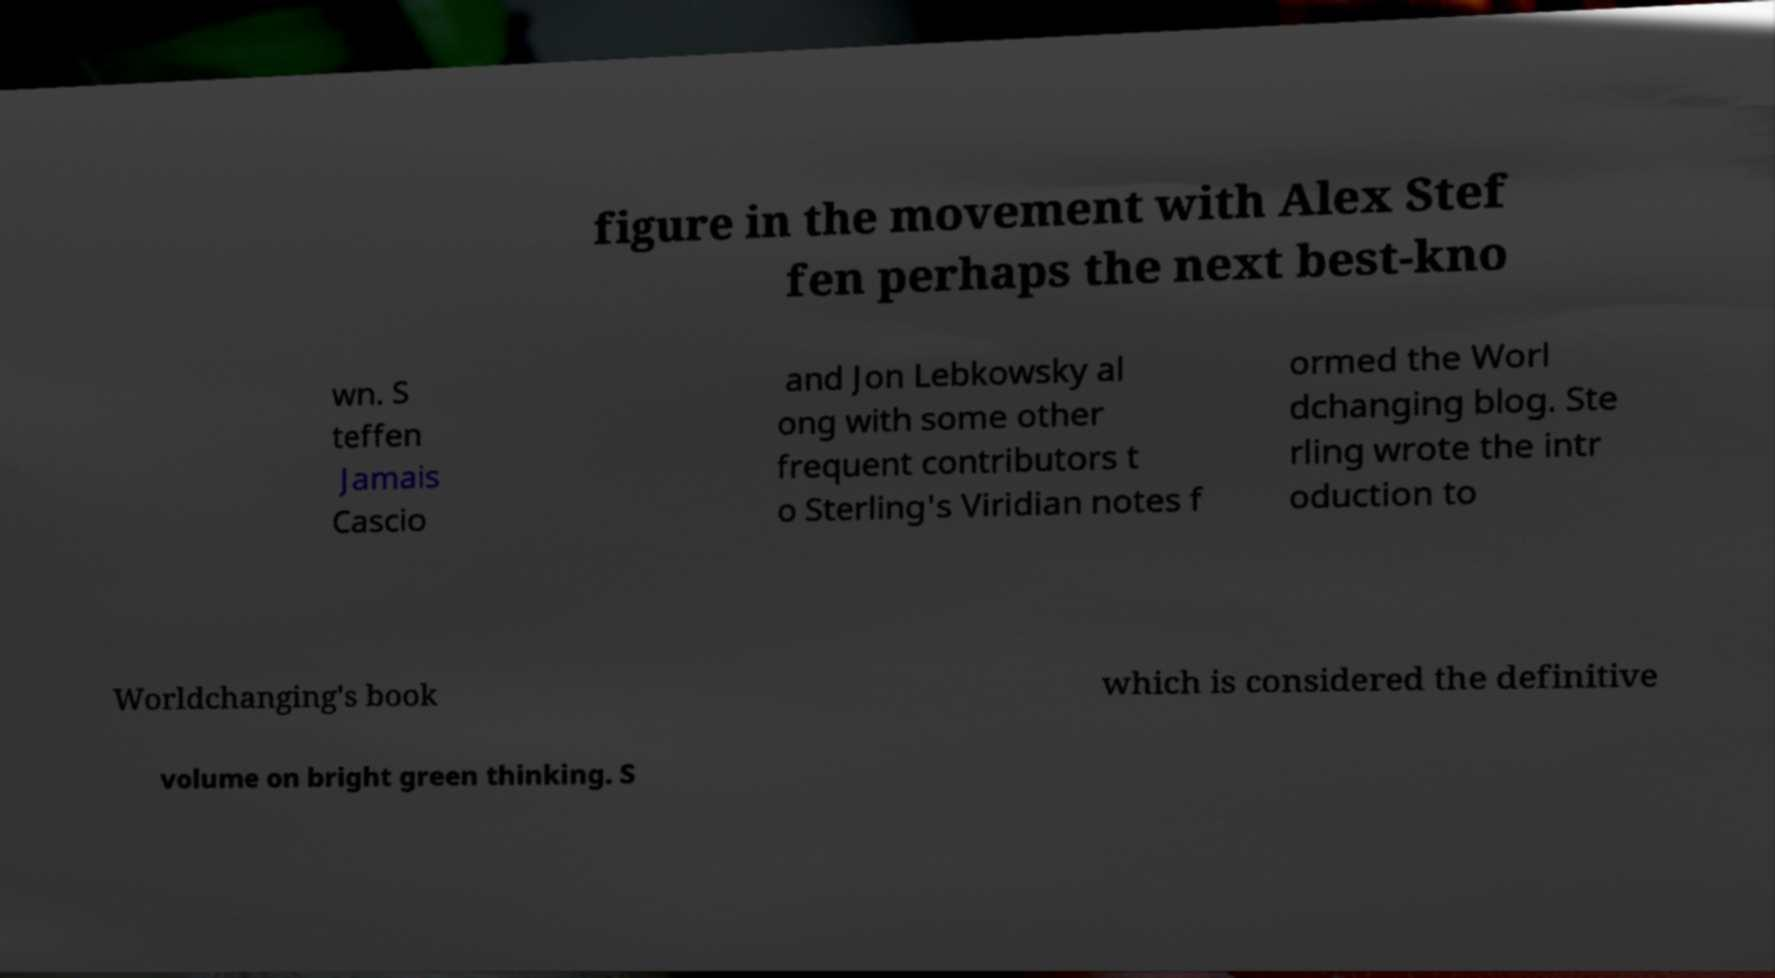Could you assist in decoding the text presented in this image and type it out clearly? figure in the movement with Alex Stef fen perhaps the next best-kno wn. S teffen Jamais Cascio and Jon Lebkowsky al ong with some other frequent contributors t o Sterling's Viridian notes f ormed the Worl dchanging blog. Ste rling wrote the intr oduction to Worldchanging's book which is considered the definitive volume on bright green thinking. S 